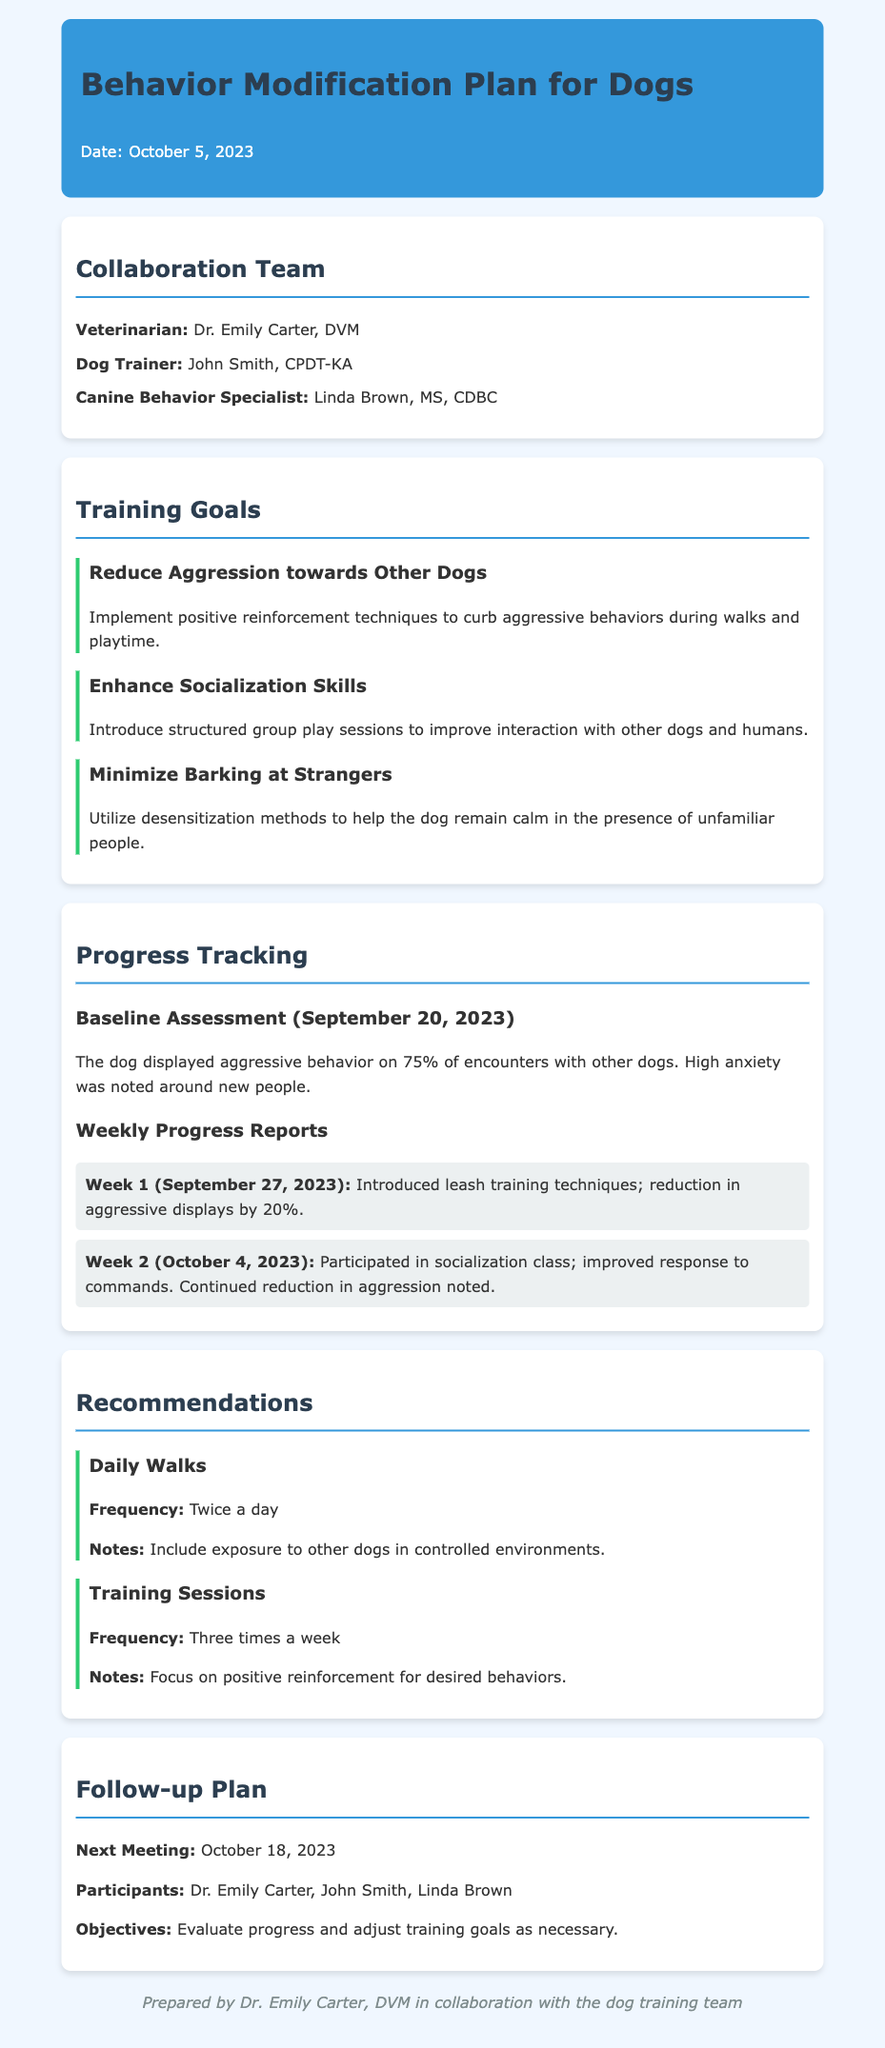What is the title of the document? The title of the document is presented in the header section.
Answer: Behavior Modification Plan for Dogs Who prepared the document? The preparation credit can be found in the footer section of the document.
Answer: Dr. Emily Carter, DVM What is the date of the baseline assessment? The date is mentioned under the progress tracking section as it relates to the initial assessment.
Answer: September 20, 2023 How much did aggressive displays reduce by in Week 1? The specific reduction percentage is detailed in the weekly progress reports section.
Answer: 20% What is the next meeting date listed in the follow-up plan? The next meeting date is specified under the follow-up plan section.
Answer: October 18, 2023 How many times a week are training sessions recommended? The recommended frequency for training sessions is stated in the recommendations section.
Answer: Three times a week What is the main goal for reducing barking? The goal is explicitly mentioned in the training goals section of the document.
Answer: Minimize Barking at Strangers Who is the Canine Behavior Specialist involved? This information is provided in the collaboration team section of the document.
Answer: Linda Brown, MS, CDBC What type of techniques are suggested to curb aggressive behaviors? The document mentions specific techniques aimed at managing aggression in the goals section.
Answer: Positive reinforcement techniques 